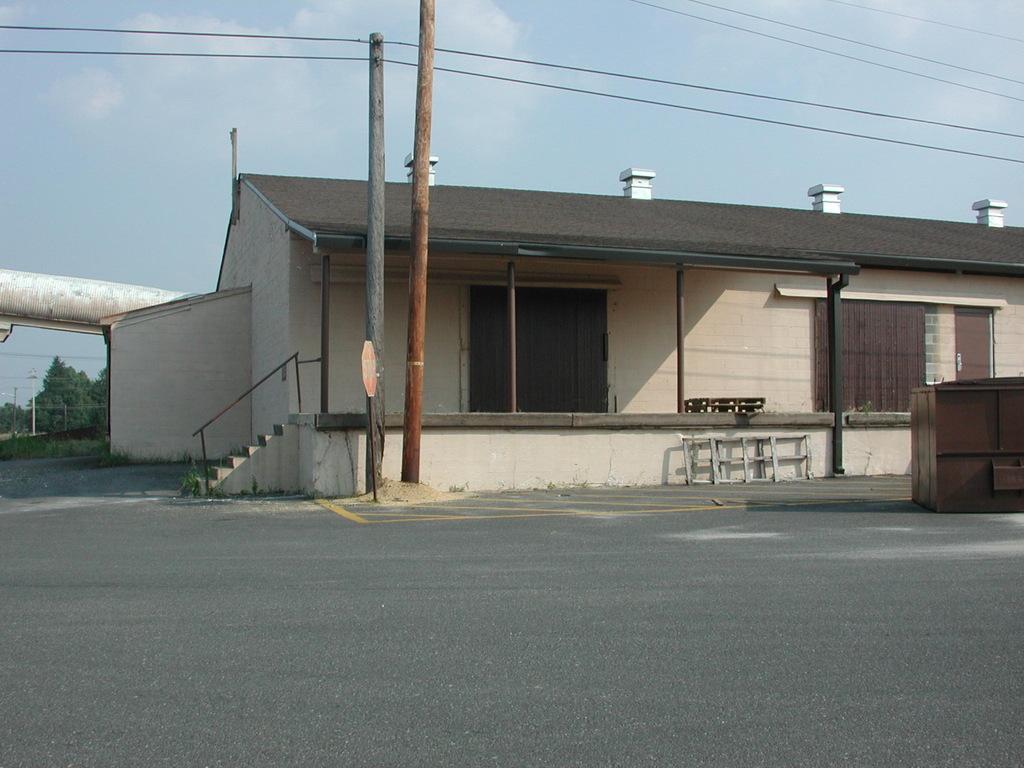How would you summarize this image in a sentence or two? In this image, there is a road, there are two poles, there are some electric cables passing from the poles, there is a house and at the left side there are some green color trees, at the top there is a sky. 